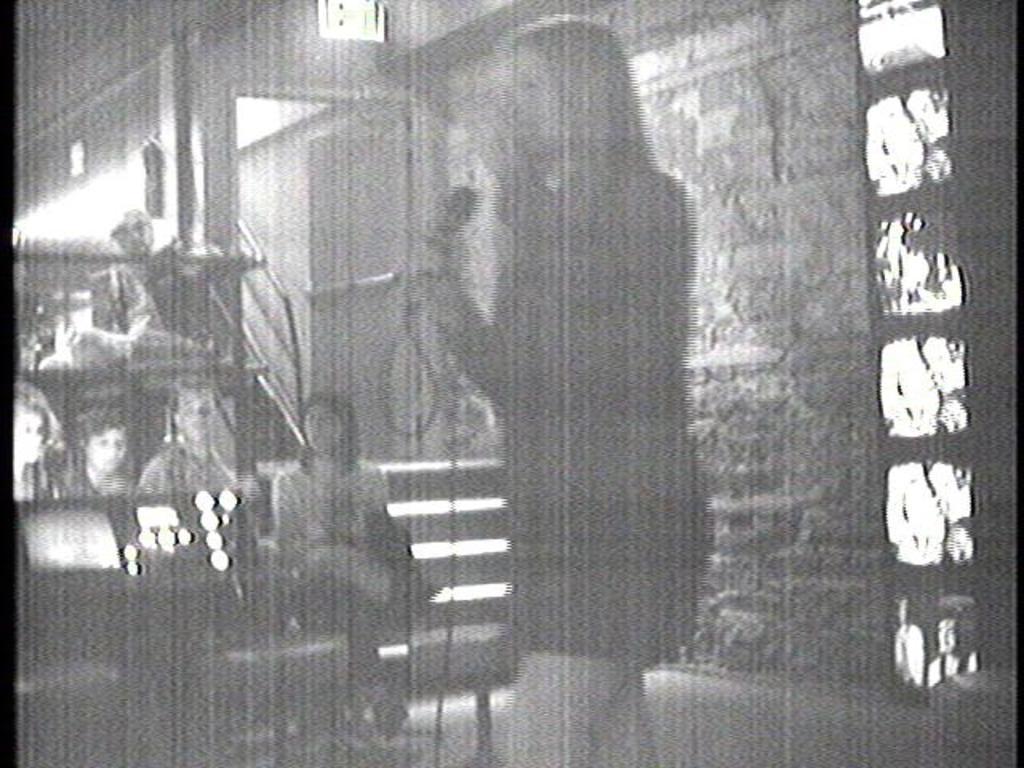Please provide a concise description of this image. It is a black and white image, there is a woman she is holding a mic in her hand and beside the woman some people were sitting and paying attention towards her, beside the people there are stairs towards the door and the door is open and beside the door there is a wall. 